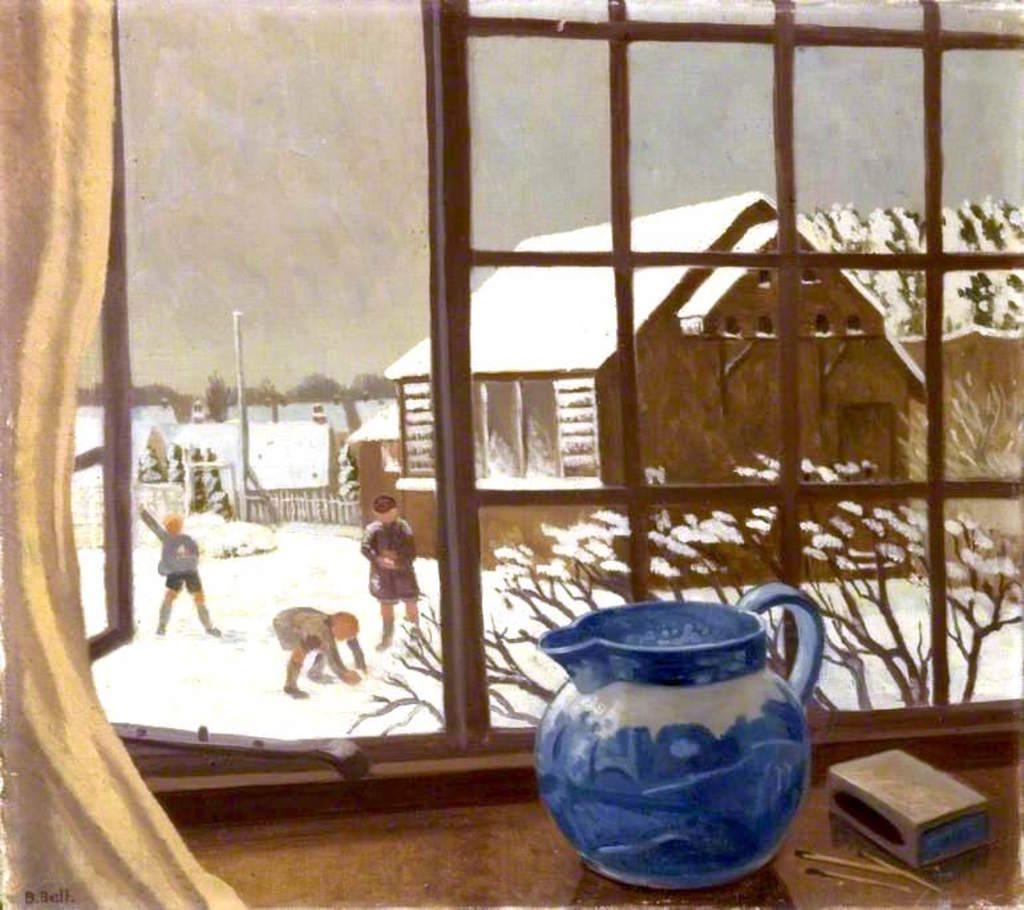Can you describe this image briefly? This image looks like a painting. In the front there is a window in which there is a match box and a jug. To the left, there is a curtain. Through the window there are three person and a small house along with the snow all over the image are seen. 